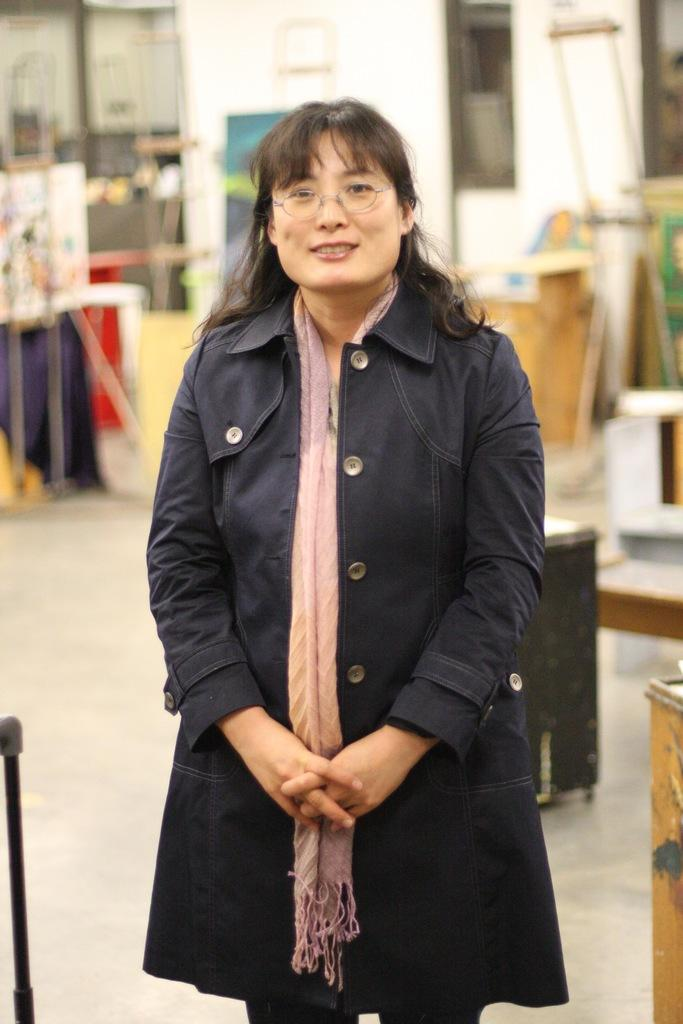Who is the main subject in the image? There is a lady standing in the center of the image. What is the lady wearing? The lady is wearing a coat. What can be seen in the background of the image? There are tables and a wall in the background of the image. What type of drug is the lady holding in the image? There is no drug present in the image; the lady is simply standing and wearing a coat. Can you tell me how many goldfish are swimming in the background of the image? There are no goldfish present in the image; the background features tables and a wall. 